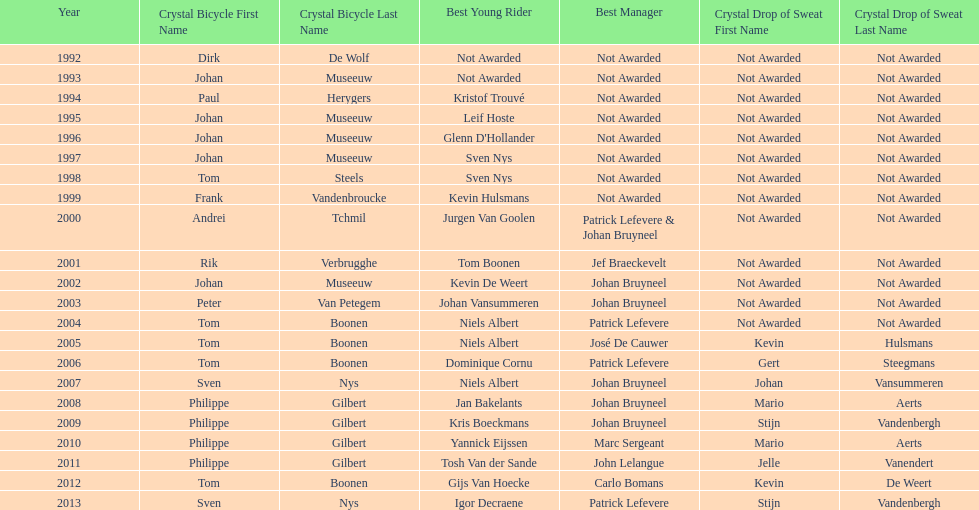Help me parse the entirety of this table. {'header': ['Year', 'Crystal Bicycle First Name', 'Crystal Bicycle Last Name', 'Best Young Rider', 'Best Manager', 'Crystal Drop of Sweat First Name', 'Crystal Drop of Sweat Last Name'], 'rows': [['1992', 'Dirk', 'De Wolf', 'Not Awarded', 'Not Awarded', 'Not Awarded', 'Not Awarded'], ['1993', 'Johan', 'Museeuw', 'Not Awarded', 'Not Awarded', 'Not Awarded', 'Not Awarded'], ['1994', 'Paul', 'Herygers', 'Kristof Trouvé', 'Not Awarded', 'Not Awarded', 'Not Awarded'], ['1995', 'Johan', 'Museeuw', 'Leif Hoste', 'Not Awarded', 'Not Awarded', 'Not Awarded'], ['1996', 'Johan', 'Museeuw', "Glenn D'Hollander", 'Not Awarded', 'Not Awarded', 'Not Awarded'], ['1997', 'Johan', 'Museeuw', 'Sven Nys', 'Not Awarded', 'Not Awarded', 'Not Awarded'], ['1998', 'Tom', 'Steels', 'Sven Nys', 'Not Awarded', 'Not Awarded', 'Not Awarded'], ['1999', 'Frank', 'Vandenbroucke', 'Kevin Hulsmans', 'Not Awarded', 'Not Awarded', 'Not Awarded'], ['2000', 'Andrei', 'Tchmil', 'Jurgen Van Goolen', 'Patrick Lefevere & Johan Bruyneel', 'Not Awarded', 'Not Awarded'], ['2001', 'Rik', 'Verbrugghe', 'Tom Boonen', 'Jef Braeckevelt', 'Not Awarded', 'Not Awarded'], ['2002', 'Johan', 'Museeuw', 'Kevin De Weert', 'Johan Bruyneel', 'Not Awarded', 'Not Awarded'], ['2003', 'Peter', 'Van Petegem', 'Johan Vansummeren', 'Johan Bruyneel', 'Not Awarded', 'Not Awarded'], ['2004', 'Tom', 'Boonen', 'Niels Albert', 'Patrick Lefevere', 'Not Awarded', 'Not Awarded'], ['2005', 'Tom', 'Boonen', 'Niels Albert', 'José De Cauwer', 'Kevin', 'Hulsmans'], ['2006', 'Tom', 'Boonen', 'Dominique Cornu', 'Patrick Lefevere', 'Gert', 'Steegmans'], ['2007', 'Sven', 'Nys', 'Niels Albert', 'Johan Bruyneel', 'Johan', 'Vansummeren'], ['2008', 'Philippe', 'Gilbert', 'Jan Bakelants', 'Johan Bruyneel', 'Mario', 'Aerts'], ['2009', 'Philippe', 'Gilbert', 'Kris Boeckmans', 'Johan Bruyneel', 'Stijn', 'Vandenbergh'], ['2010', 'Philippe', 'Gilbert', 'Yannick Eijssen', 'Marc Sergeant', 'Mario', 'Aerts'], ['2011', 'Philippe', 'Gilbert', 'Tosh Van der Sande', 'John Lelangue', 'Jelle', 'Vanendert'], ['2012', 'Tom', 'Boonen', 'Gijs Van Hoecke', 'Carlo Bomans', 'Kevin', 'De Weert'], ['2013', 'Sven', 'Nys', 'Igor Decraene', 'Patrick Lefevere', 'Stijn', 'Vandenbergh']]} Who won the crystal bicycle earlier, boonen or nys? Tom Boonen. 